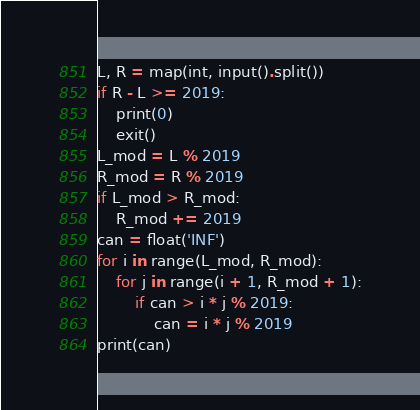<code> <loc_0><loc_0><loc_500><loc_500><_Python_>L, R = map(int, input().split())
if R - L >= 2019:
    print(0)
    exit()
L_mod = L % 2019
R_mod = R % 2019
if L_mod > R_mod:
    R_mod += 2019
can = float('INF')
for i in range(L_mod, R_mod):
    for j in range(i + 1, R_mod + 1):
        if can > i * j % 2019:
            can = i * j % 2019
print(can)
</code> 